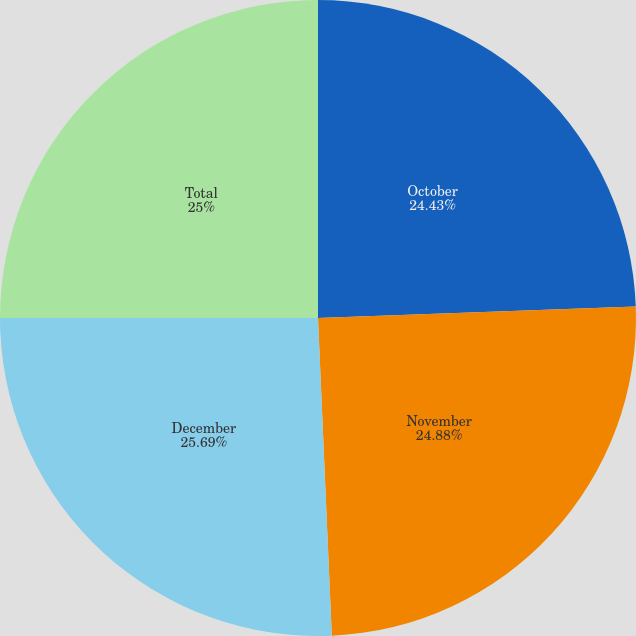<chart> <loc_0><loc_0><loc_500><loc_500><pie_chart><fcel>October<fcel>November<fcel>December<fcel>Total<nl><fcel>24.43%<fcel>24.88%<fcel>25.69%<fcel>25.0%<nl></chart> 